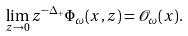<formula> <loc_0><loc_0><loc_500><loc_500>\lim _ { z \rightarrow 0 } z ^ { - \Delta _ { + } } \Phi _ { \omega } ( x , z ) = \mathcal { O } _ { \omega } ( x ) .</formula> 